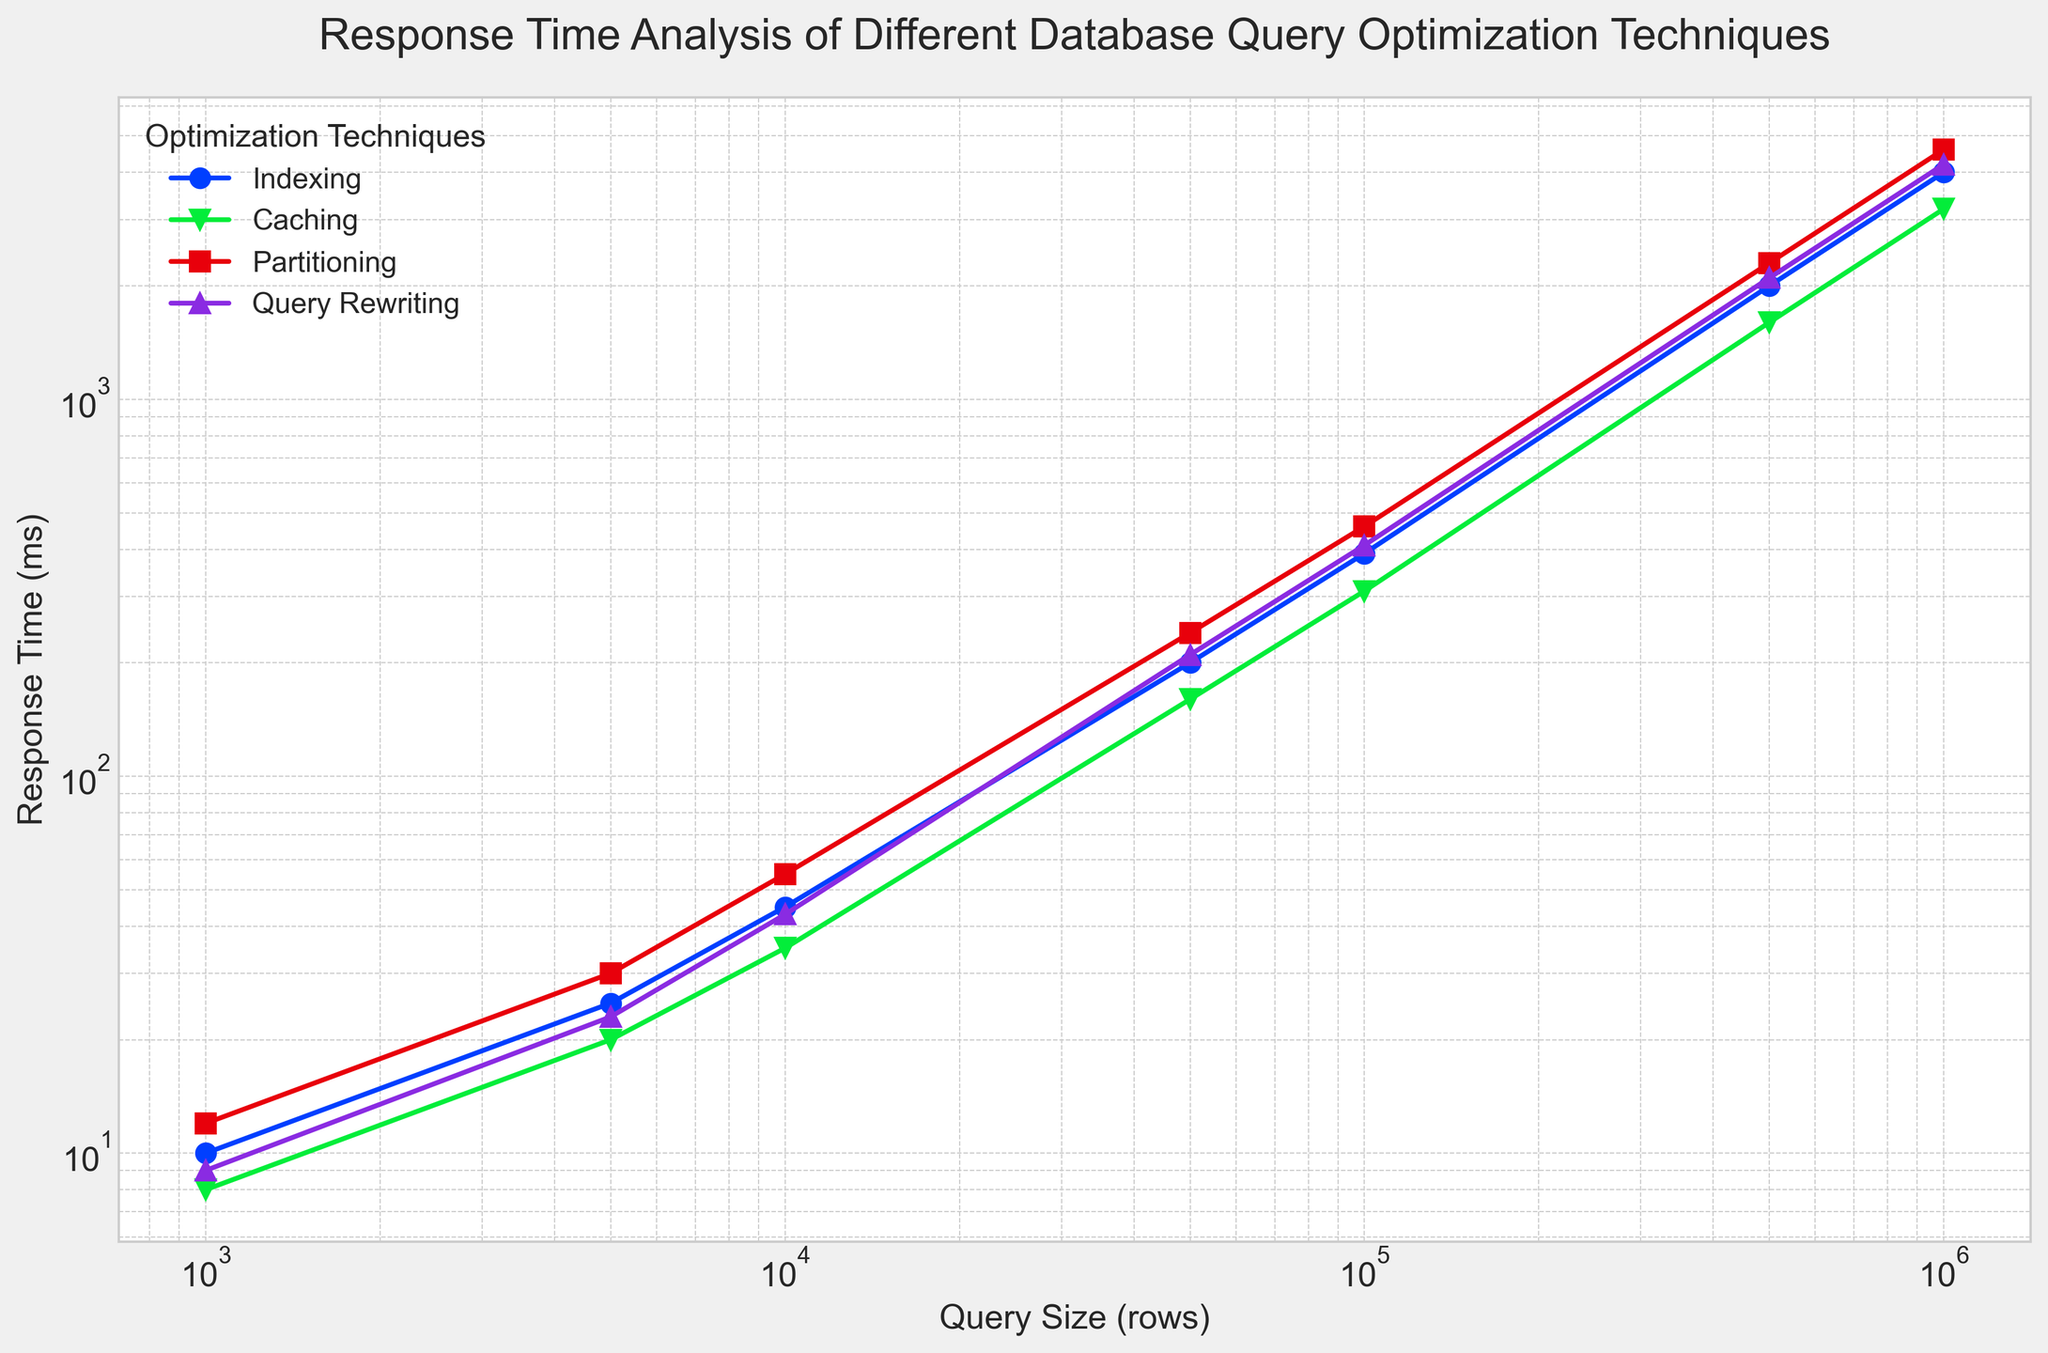What optimization technique has the lowest response time for a query size of 100,000 rows? For a query size of 100,000 rows, locate each technique's response time on the y-axis, and compare them: Indexing (390 ms), Caching (310 ms), Partitioning (460 ms), Query Rewriting (410 ms). Caching has the lowest response time.
Answer: Caching As query size increases from 1,000 rows to 1,000,000 rows, which optimization technique shows the smallest relative increase in response time? Determine the response time increase for each technique from 1,000 to 1,000,000 rows and find the relative increase: Indexing (10 ms to 4000 ms), Caching (8 ms to 3200 ms), Partitioning (12 ms to 4600 ms), Query Rewriting (9 ms to 4200 ms). Caching shows the smallest relative increase.
Answer: Caching For a query size of 50,000 rows, which optimization technique has the highest response time? For 50,000 rows, look at the response times from the figure: Indexing (200 ms), Caching (160 ms), Partitioning (240 ms), Query Rewriting (210 ms). Partitioning has the highest response time.
Answer: Partitioning Compare the response times of Indexing and Query Rewriting for a query size of 10,000 rows. Which is faster and by how much? Locate the response times for Indexing and Query Rewriting at 10,000 rows: Indexing (45 ms) and Query Rewriting (43 ms). Indexing is slower than Query Rewriting by 2 ms.
Answer: Query Rewriting, 2 ms At which query size does the response time of Caching become greater than 1000 ms for the first time? Inspect the response time for Caching across various query sizes. The response time exceeds 1000 ms for the first time at 500,000 rows (1600 ms).
Answer: 500,000 rows Rank the optimization techniques from fastest to slowest for a query size of 5,000 rows. Reference the response times for each technique at 5,000 rows: Indexing (25 ms), Caching (20 ms), Partitioning (30 ms), Query Rewriting (23 ms). The ordered ranking is Caching, Query Rewriting, Indexing, Partitioning.
Answer: Caching, Query Rewriting, Indexing, Partitioning For the query size of 1000 rows, which optimization technique and by what percentage is faster compared to the slowest one? Find response times for 1000 rows: Indexing (10 ms), Caching (8 ms), Partitioning (12 ms), Query Rewriting (9 ms). Caching is the fastest, and Partitioning is the slowest. Calculate percentage difference: ((12 - 8) / 12) * 100 = 33.33%.
Answer: Caching, 33.33% How does the response time of Partitioning compare to Indexing for a query size of 100,000 rows? Check the response times for Partitioning and Indexing at 100,000 rows: Partitioning (460 ms) and Indexing (390 ms). Calculate the difference: 460 ms - 390 ms = 70 ms. Partitioning is 70 ms slower.
Answer: Partitioning is 70 ms slower 